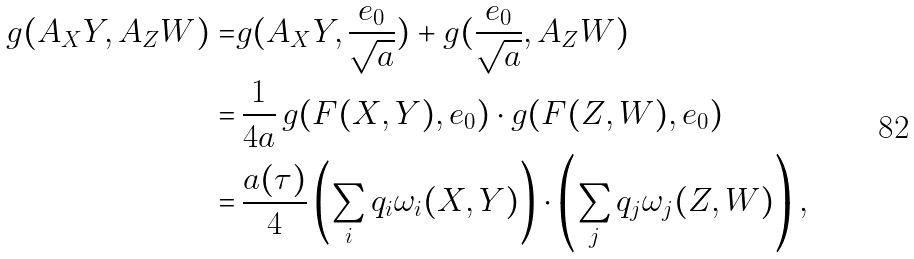<formula> <loc_0><loc_0><loc_500><loc_500>g ( A _ { X } Y , A _ { Z } W ) = & g ( A _ { X } Y , \frac { e _ { 0 } } { \sqrt { a } } ) + g ( \frac { e _ { 0 } } { \sqrt { a } } , A _ { Z } W ) \\ = & \, \frac { 1 } { 4 a } \, g ( F ( X , Y ) , e _ { 0 } ) \cdot g ( F ( Z , W ) , e _ { 0 } ) \\ = & \, \frac { a ( \tau ) } { 4 } \left ( \sum _ { i } q _ { i } \omega _ { i } ( X , Y ) \right ) \cdot \left ( \sum _ { j } q _ { j } \omega _ { j } ( Z , W ) \right ) ,</formula> 